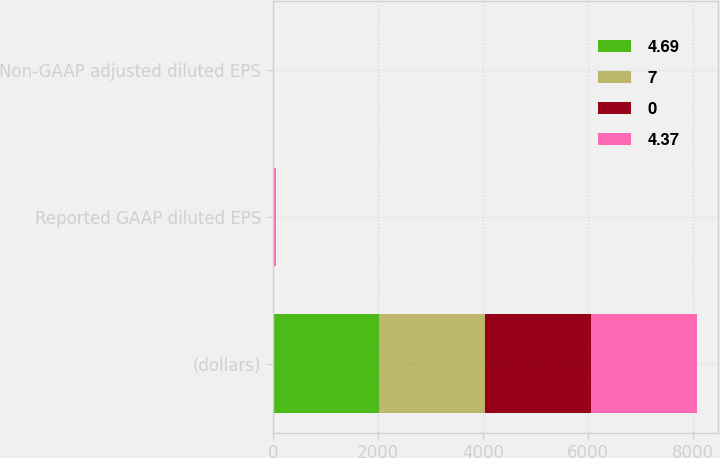<chart> <loc_0><loc_0><loc_500><loc_500><stacked_bar_chart><ecel><fcel>(dollars)<fcel>Reported GAAP diluted EPS<fcel>Non-GAAP adjusted diluted EPS<nl><fcel>4.69<fcel>2017<fcel>5.13<fcel>4.69<nl><fcel>7<fcel>2016<fcel>4.14<fcel>4.37<nl><fcel>0<fcel>2017<fcel>24<fcel>7<nl><fcel>4.37<fcel>2016<fcel>25<fcel>0<nl></chart> 